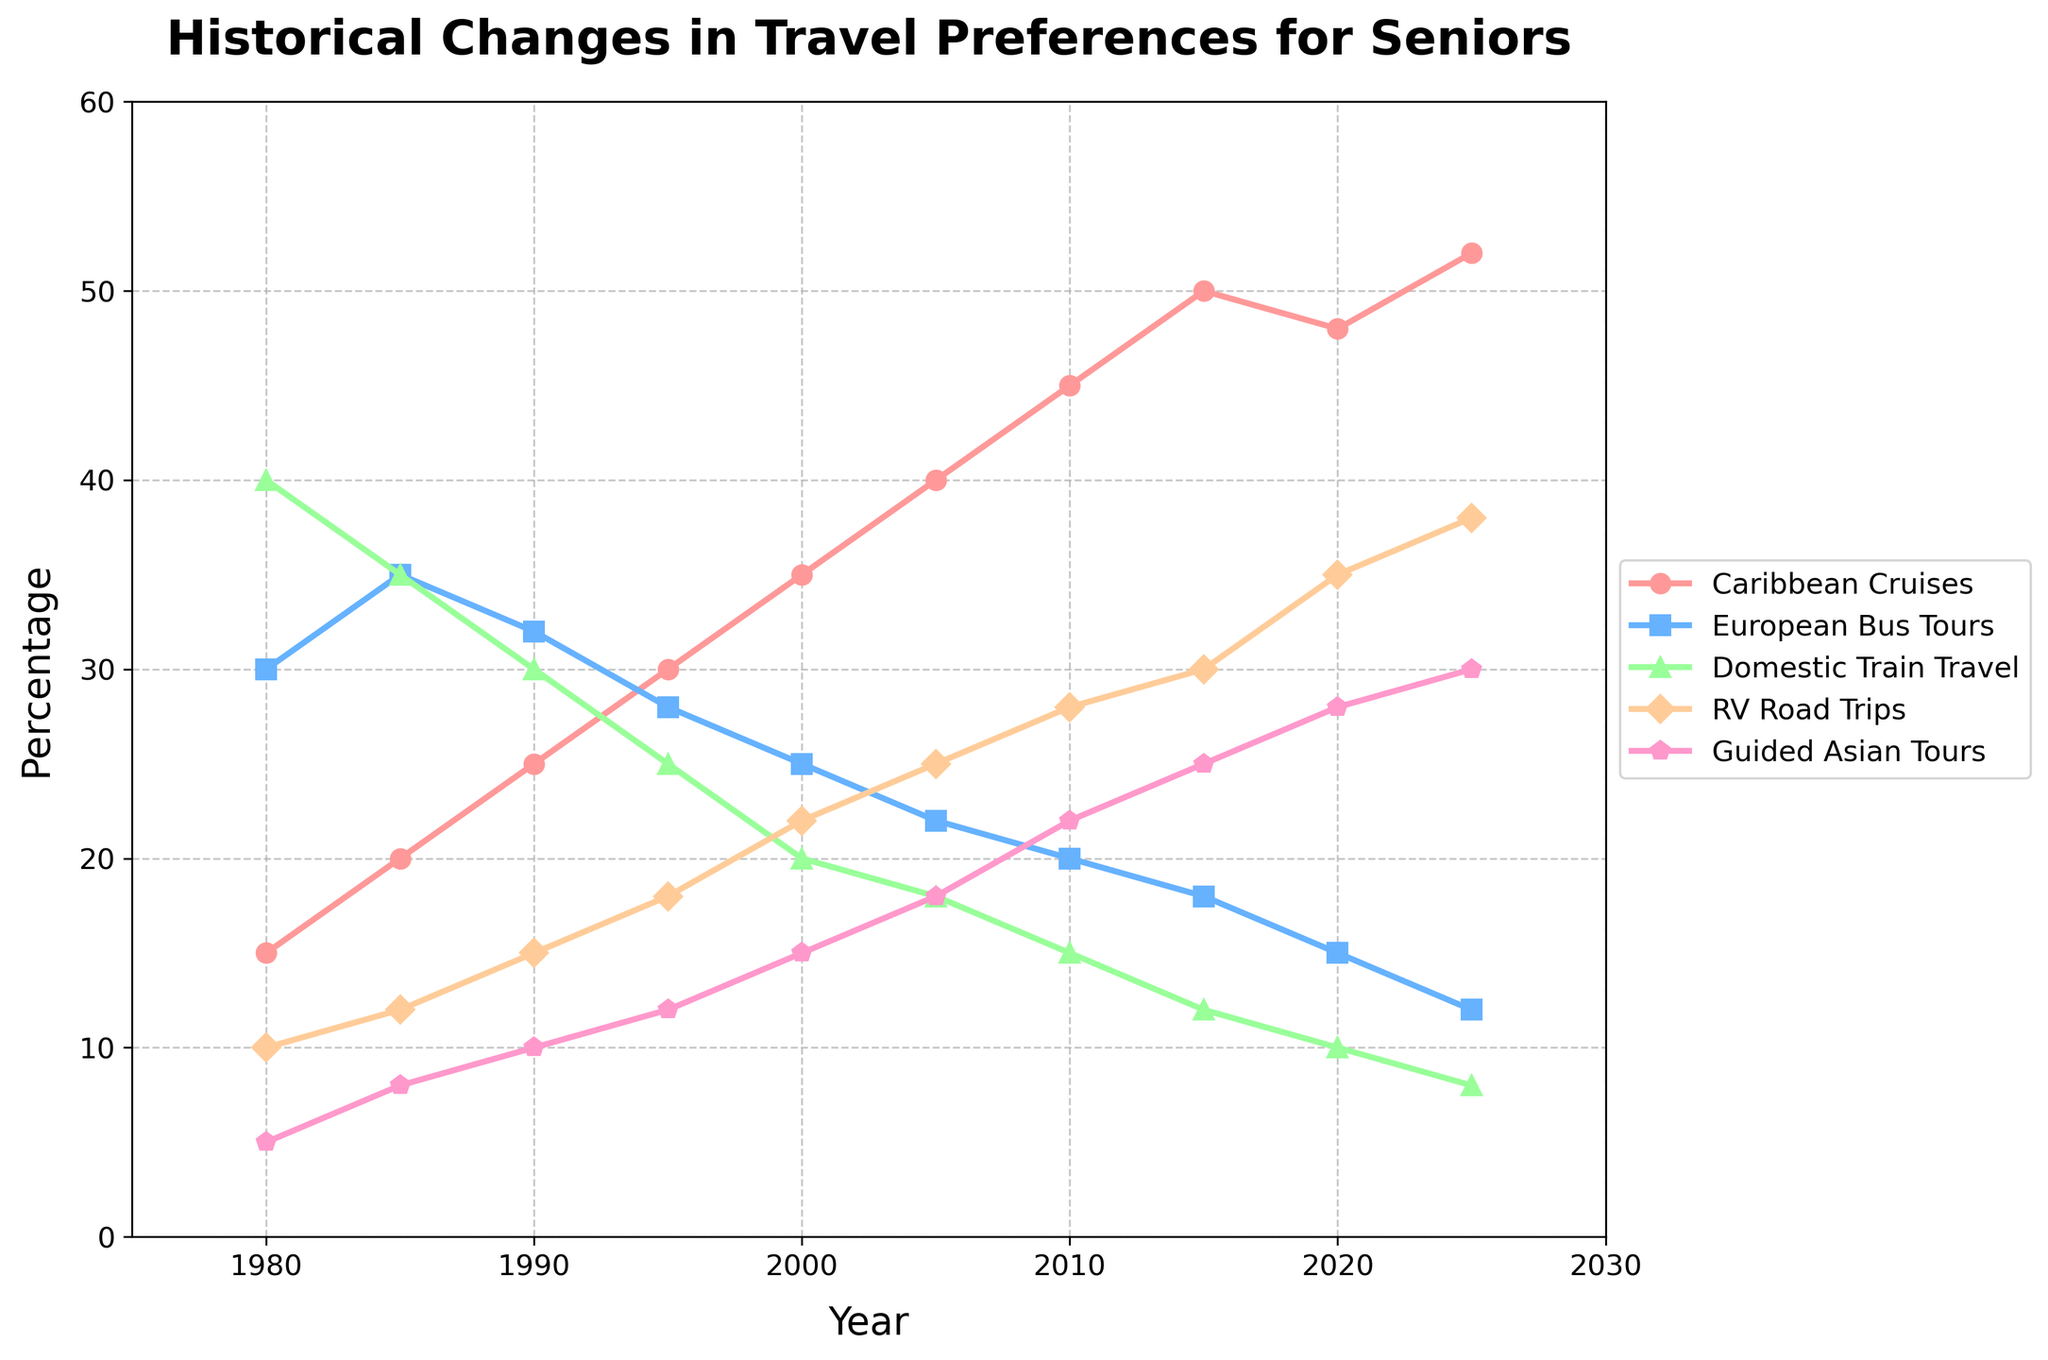What's the trend for Caribbean Cruises from 1980 to 2025? The percentage of seniors preferring Caribbean Cruises has increased steadily from 15% in 1980 to 52% in 2025. This upward trend can be observed clearly by following the line associated with Caribbean Cruises, which rises consistently over the years.
Answer: Upward In which year did European Bus Tours surpass Domestic Train Travel in popularity? European Bus Tours held a higher percentage than Domestic Train Travel from 1980 until 1990. From 1995 onwards, Domestic Train Travel consistently had a lower percentage compared to European Bus Tours. Thus, 1985 is the last year when European Bus Tours had a higher percentage, with 35% compared to Domestic Train Travel's 35%.
Answer: 1985 What is the largest percentage recorded for RV Road Trips, and in which year did it occur? By following the line representing RV Road Trips and looking for the peak value, the highest percentage is recorded at 38% in 2025.
Answer: 38%, 2025 How does the increase in preference for Guided Asian Tours from 1980 to 2025 compare to the increase in Caribbean Cruises in the same period? Caribbean Cruises increased from 15% in 1980 to 52% in 2025, which is an increase of 37 percentage points. Guided Asian Tours increased from 5% in 1980 to 30% in 2025, which is an increase of 25 percentage points.
Answer: 37 percentage points for Caribbean Cruises, 25 percentage points for Guided Asian Tours Is there any period where the percentage for Domestic Train Travel remained the same or did not decrease? The percentage for Domestic Train Travel remained the same between 1980 and 1985, holding steady at 40%, before starting to decrease in the following years.
Answer: 1980 to 1985 What is the percentage difference between the most and least popular travel preferences in 2020? In 2020, RV Road Trips (35%) was the most popular, and Domestic Train Travel (10%) was the least popular. The difference in percentages between these two travel preferences is 35% - 10% = 25%.
Answer: 25% Which mode of transportation had the smallest decrease in preference between 1985 and 2025? European Bus Tours dropped from 35% in 1985 to 12% in 2025, a decrease of 23 percentage points. Similarly, Domestic Train Travel decreased from 40% to 8%, a decrease of 32 percentage points. Among the given data points, European Bus Tours experienced the smallest decrease.
Answer: European Bus Tours In what year did Caribbean Cruises equal RV Road Trips in popularity? Following the lines for Caribbean Cruises and RV Road Trips, they intersect approximately in 2015 with both preferences at about 50%.
Answer: 2015 What visual indicator shows the guided Asian tours' increasing popularity? The line representing Guided Asian Tours consistently ascends over the years, visually indicating a growing trend in popularity from 1980 to 2025.
Answer: Ascending line What is the combined percentage for the most popular and the least popular travel preferences in 2000? In 2000, the most popular travel preference is Caribbean Cruises at 35%, and the least popular is Guided Asian Tours at 15%. Therefore, the combined percentage is 35% + 15% = 50%.
Answer: 50% 